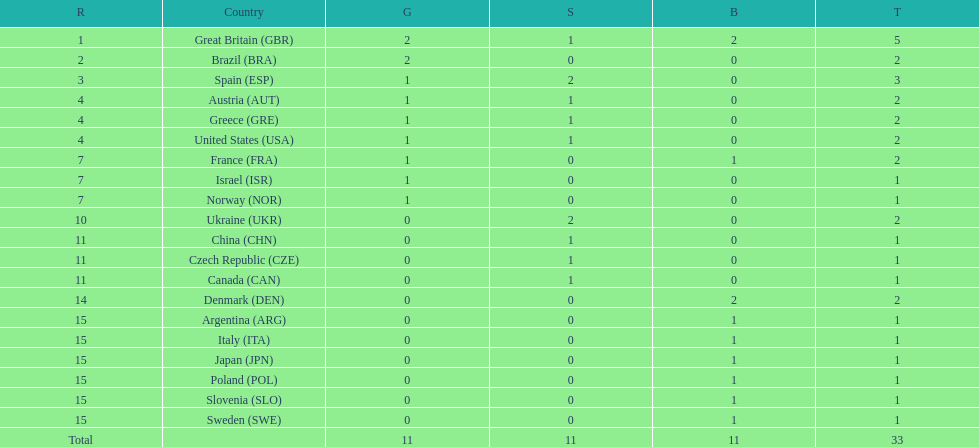What nation was next to great britain in total medal count? Spain. 